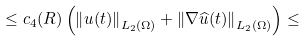Convert formula to latex. <formula><loc_0><loc_0><loc_500><loc_500>\leq c _ { 4 } ( R ) \left ( \left \| u ( t ) \right \| _ { L _ { 2 } ( \Omega ) } + \left \| \nabla \widehat { u } ( t ) \right \| _ { L _ { 2 } ( \Omega ) } \right ) \leq</formula> 